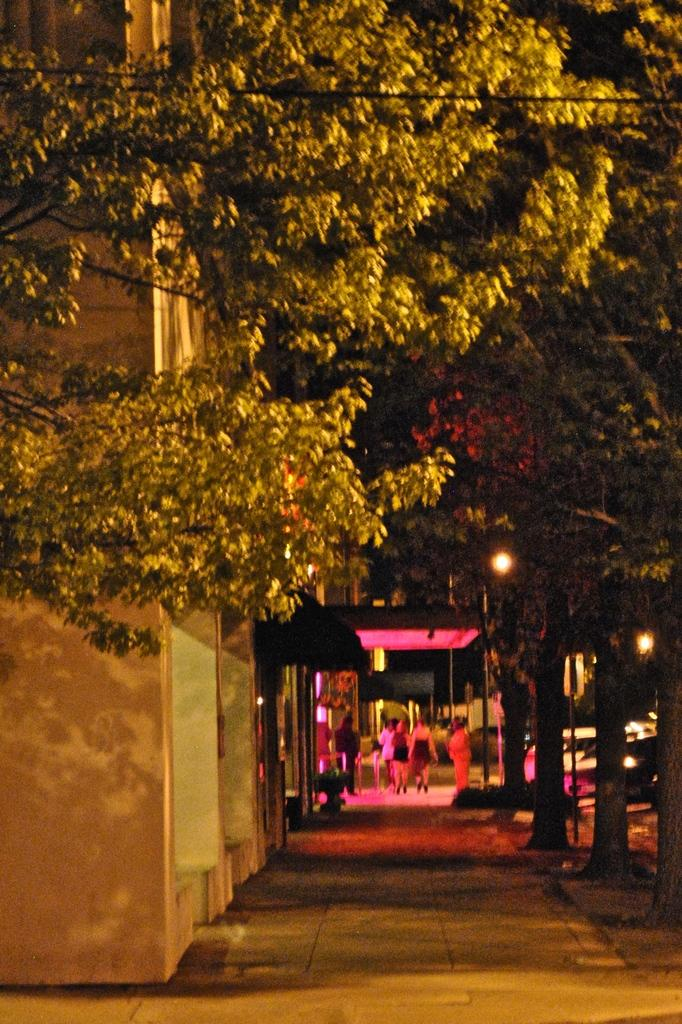What type of structure is present in the image? There is a building in the image. What can be seen in the background of the image? There are trees in the image. Who or what is present in the image? There are people in the image. What illuminates the scene in the image? There are lights in the image. What supports the lights in the image? There are poles in the image. What type of transportation is visible in the image? There are vehicles in the image. What type of plants are present in the image? There are potted plants in the image. How many eyes can be seen on the building in the image? There are no eyes present on the building in the image. What type of finger is used to operate the vehicles in the image? There are no fingers present in the image, as vehicles are operated using various controls, not fingers. 